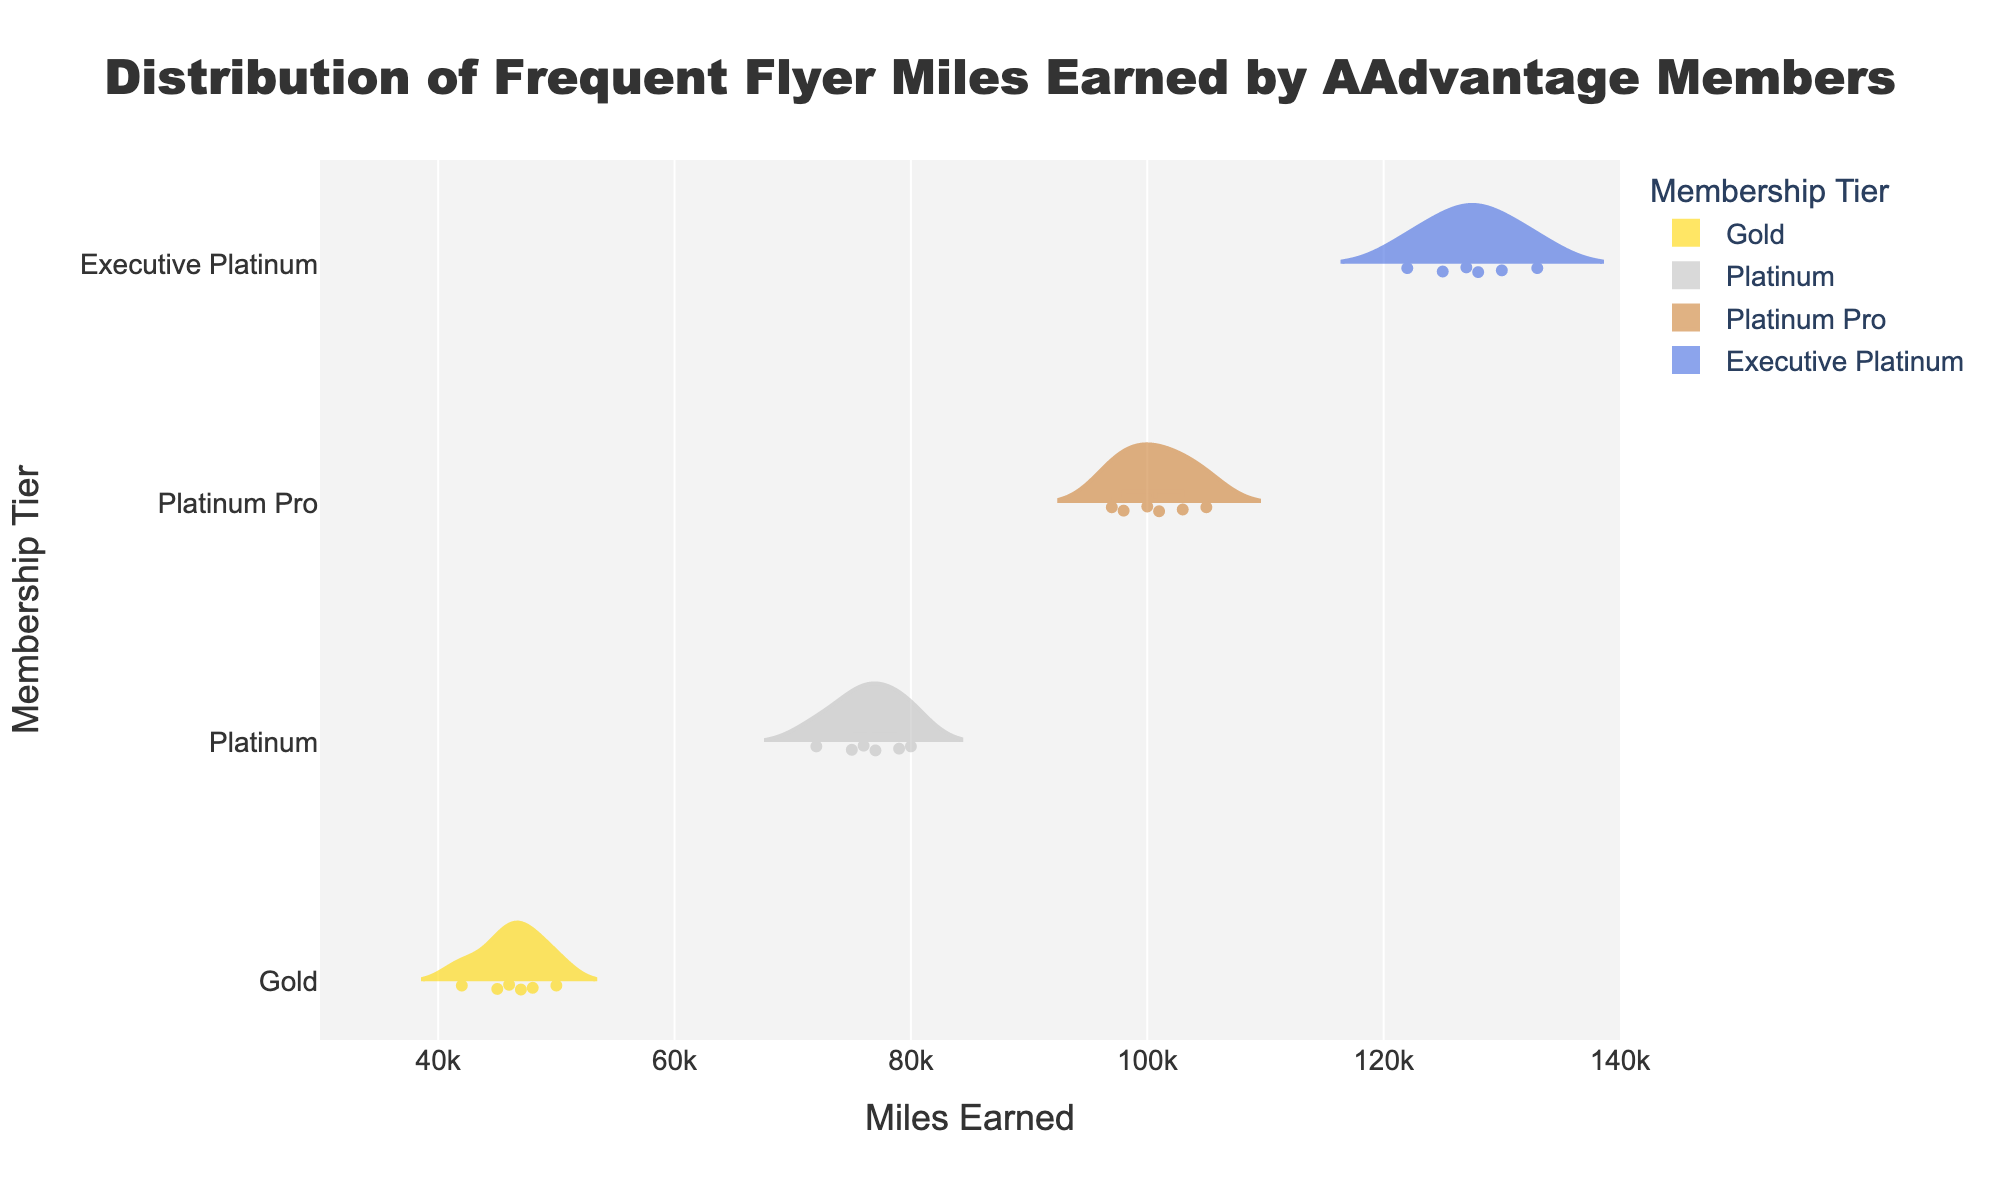What's the title of the plot? The title of the plot is typically found at the top of the graphical figure. In this case, it reads "Distribution of Frequent Flyer Miles Earned by AAdvantage Members".
Answer: Distribution of Frequent Flyer Miles Earned by AAdvantage Members What is the range of miles earned visible on the x-axis? The x-axis represents the miles earned, and we can see that it ranges from 30,000 to 140,000 miles.
Answer: 30,000 to 140,000 miles Which membership tier has the highest average miles earned? The average miles earned can be inferred from the mean lines in each violin. The "Executive Platinum" tier appears to have the highest average miles earned amongst all four tiers displayed.
Answer: Executive Platinum What is the median miles earned for the Platinum tier? The median miles earned for a group represented in a violin plot can be assessed from the box inside the plot. For the Platinum tier, the median line, the thick horizontal line inside the box, is around 76,000 miles.
Answer: 76,000 miles Which membership tier shows the widest spread of miles earned? By examining the width of the violins along the x-axis, the "Platinum Pro" and "Executive Platinum" tiers seem to have the widest spread. However, the "Executive Platinum" seems slightly broader, indicating a wider spread of miles earned.
Answer: Executive Platinum How many data points does the Gold membership tier have? The number of data points in a violin plot can be determined by the number of individual points displayed along the jittered dot plot overlay. For the Gold tier, there are 6 dots visible.
Answer: 6 Compare the maximum miles earned between the Gold and Platinum tiers. By observing the rightmost edge of the violins, the Gold tier reaches approximately 50,000 miles, while the Platinum tier extends up to around 80,000 miles. Thus, the Platinum tier has a higher maximum miles earned.
Answer: Platinum Which tier has the smallest variability in miles earned? Variability can be assessed by the spread and thickness of the violin plot. The Gold tier appears to have the narrowest and smallest spread, indicating lower variability in miles earned compared to the other tiers.
Answer: Gold What's the interquartile range (IQR) for the Platinum Pro tier? The interquartile range (IQR) is found within the box plot inside the violin. For the Platinum Pro tier, the IQR spans from about 97,000 to 103,000 miles, giving an IQR range of 103,000 - 97,000 = 6,000 miles.
Answer: 6,000 miles 